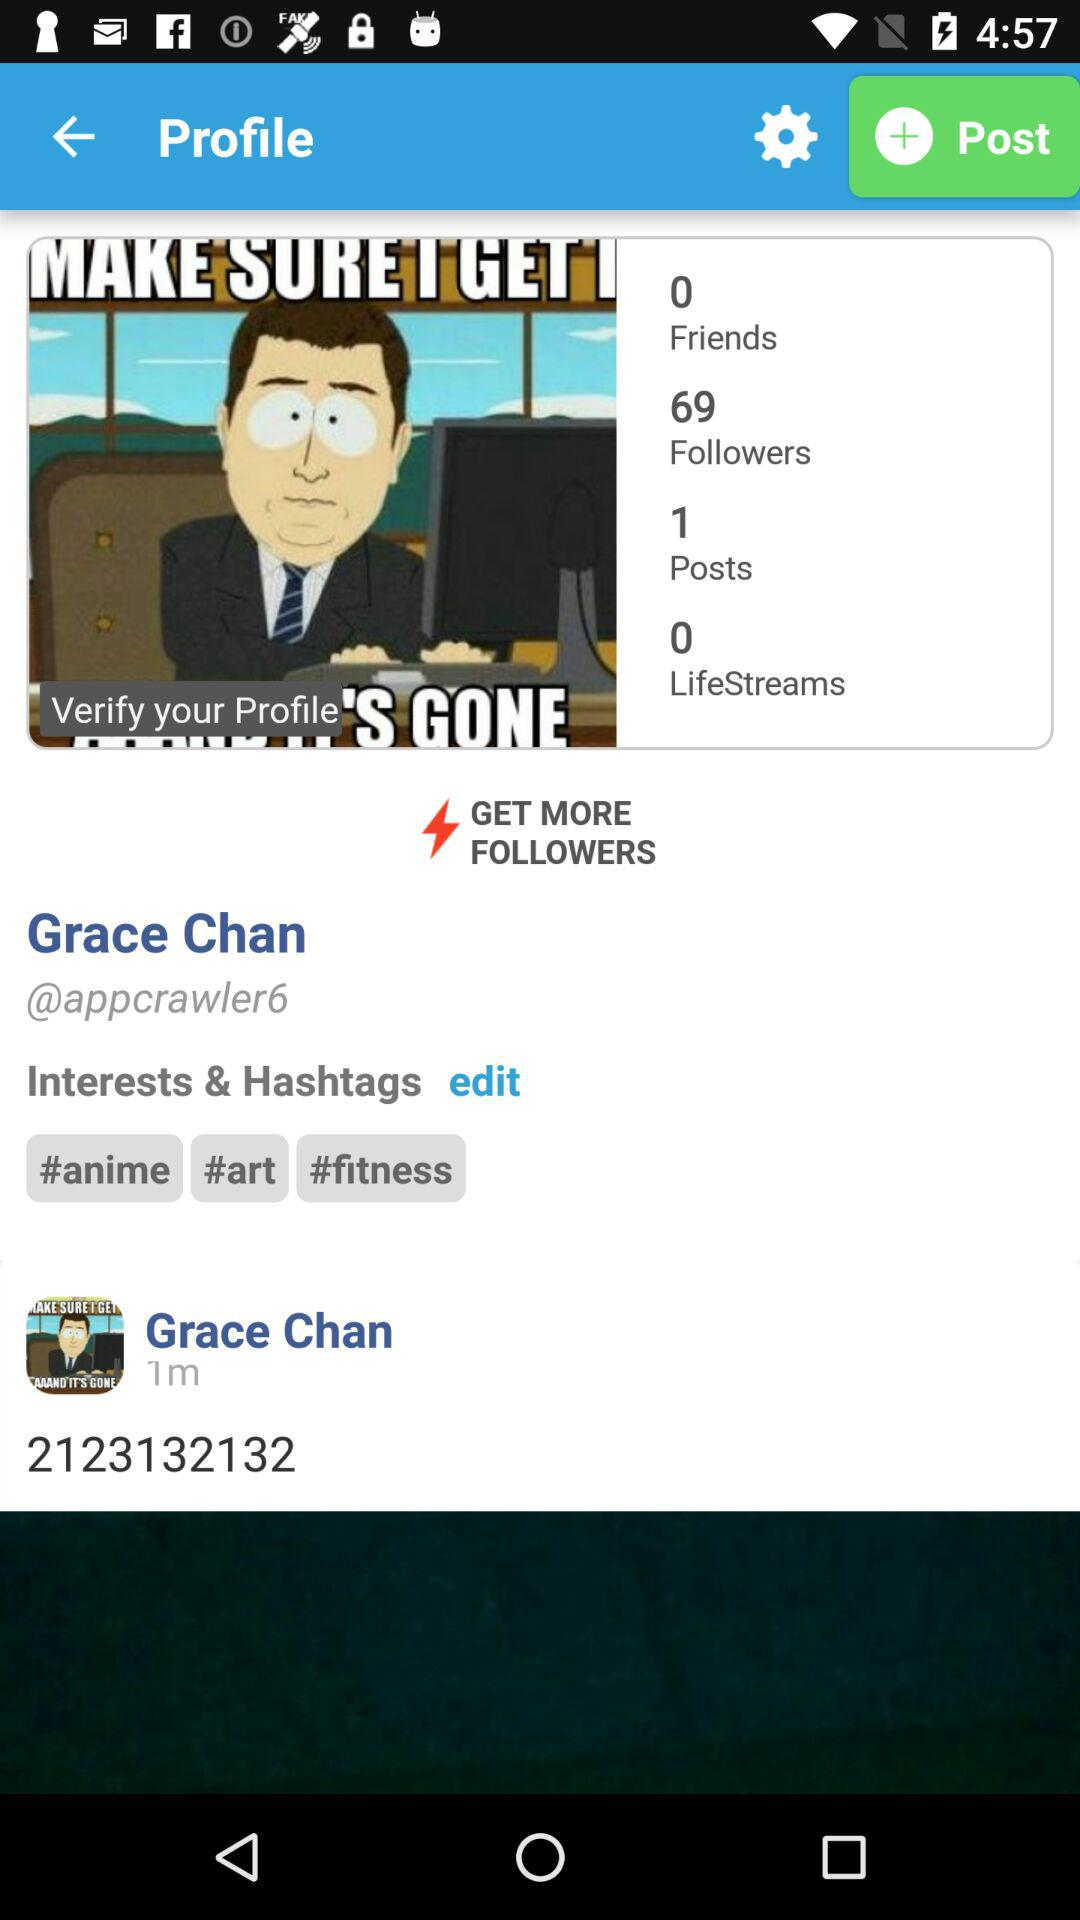What is the total number of followers? The total number of followers is 69. 